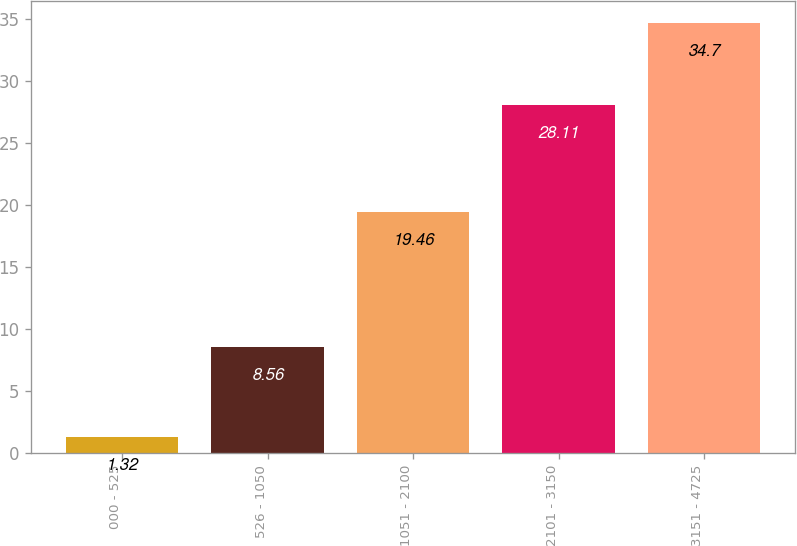<chart> <loc_0><loc_0><loc_500><loc_500><bar_chart><fcel>000 - 525<fcel>526 - 1050<fcel>1051 - 2100<fcel>2101 - 3150<fcel>3151 - 4725<nl><fcel>1.32<fcel>8.56<fcel>19.46<fcel>28.11<fcel>34.7<nl></chart> 